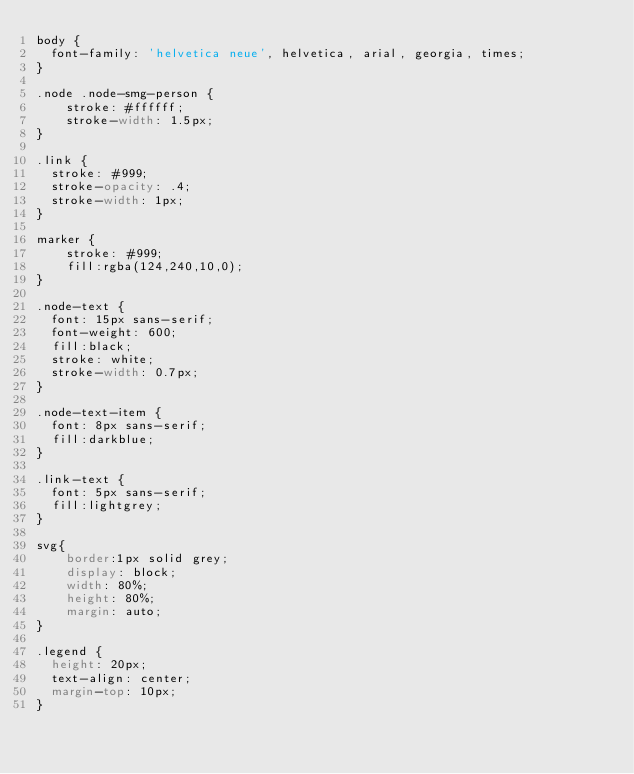<code> <loc_0><loc_0><loc_500><loc_500><_CSS_>body {
  font-family: 'helvetica neue', helvetica, arial, georgia, times;
}

.node .node-smg-person {
    stroke: #ffffff;
    stroke-width: 1.5px;
}

.link {
  stroke: #999;
  stroke-opacity: .4;
  stroke-width: 1px;
}

marker {
    stroke: #999;
    fill:rgba(124,240,10,0);
}

.node-text {
  font: 15px sans-serif;
  font-weight: 600;
  fill:black;
  stroke: white;
  stroke-width: 0.7px;
}

.node-text-item {
  font: 8px sans-serif;
  fill:darkblue;
}

.link-text {
  font: 5px sans-serif;
  fill:lightgrey;
}

svg{
    border:1px solid grey;
    display: block;
    width: 80%;
    height: 80%;
    margin: auto;
}

.legend {
  height: 20px;
  text-align: center;
  margin-top: 10px;
}</code> 